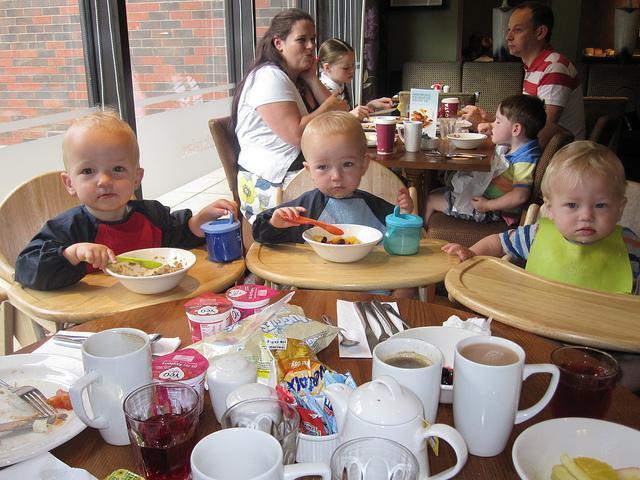How many kids are there?
Give a very brief answer. 5. How many cups can you see?
Give a very brief answer. 8. How many bowls are in the picture?
Give a very brief answer. 3. How many people can be seen?
Give a very brief answer. 7. How many dining tables are there?
Give a very brief answer. 2. How many chairs are in the photo?
Give a very brief answer. 5. 